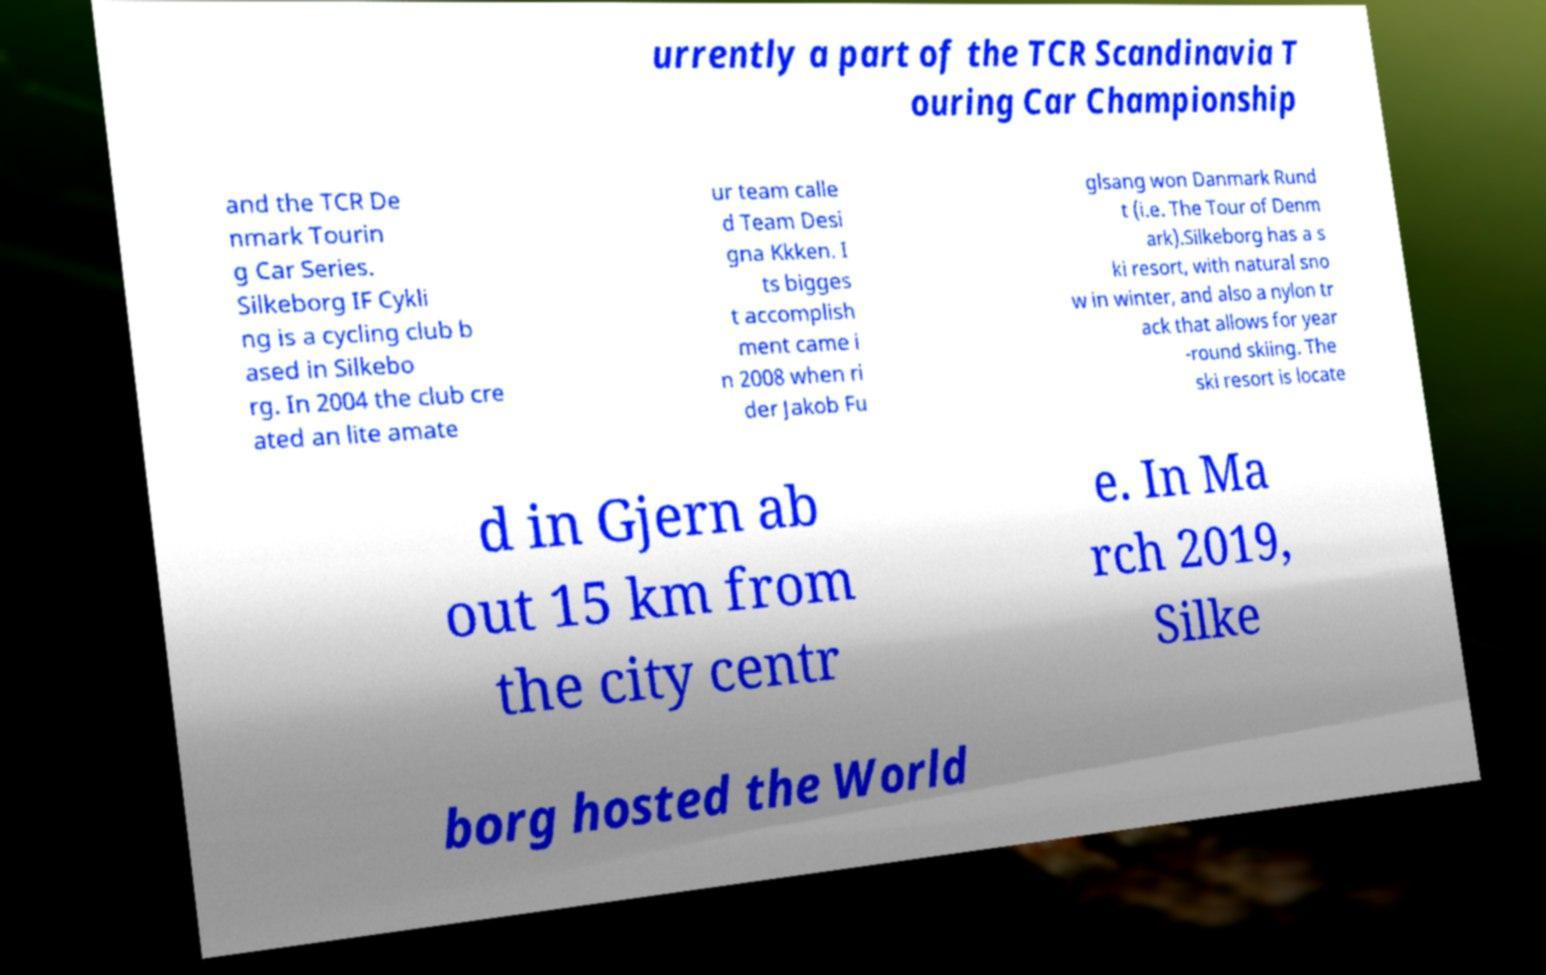Please read and relay the text visible in this image. What does it say? urrently a part of the TCR Scandinavia T ouring Car Championship and the TCR De nmark Tourin g Car Series. Silkeborg IF Cykli ng is a cycling club b ased in Silkebo rg. In 2004 the club cre ated an lite amate ur team calle d Team Desi gna Kkken. I ts bigges t accomplish ment came i n 2008 when ri der Jakob Fu glsang won Danmark Rund t (i.e. The Tour of Denm ark).Silkeborg has a s ki resort, with natural sno w in winter, and also a nylon tr ack that allows for year -round skiing. The ski resort is locate d in Gjern ab out 15 km from the city centr e. In Ma rch 2019, Silke borg hosted the World 